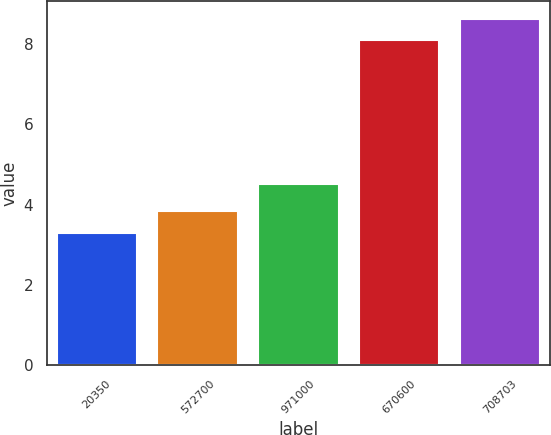Convert chart to OTSL. <chart><loc_0><loc_0><loc_500><loc_500><bar_chart><fcel>20350<fcel>572700<fcel>971000<fcel>670600<fcel>708703<nl><fcel>3.3<fcel>3.83<fcel>4.5<fcel>8.1<fcel>8.63<nl></chart> 